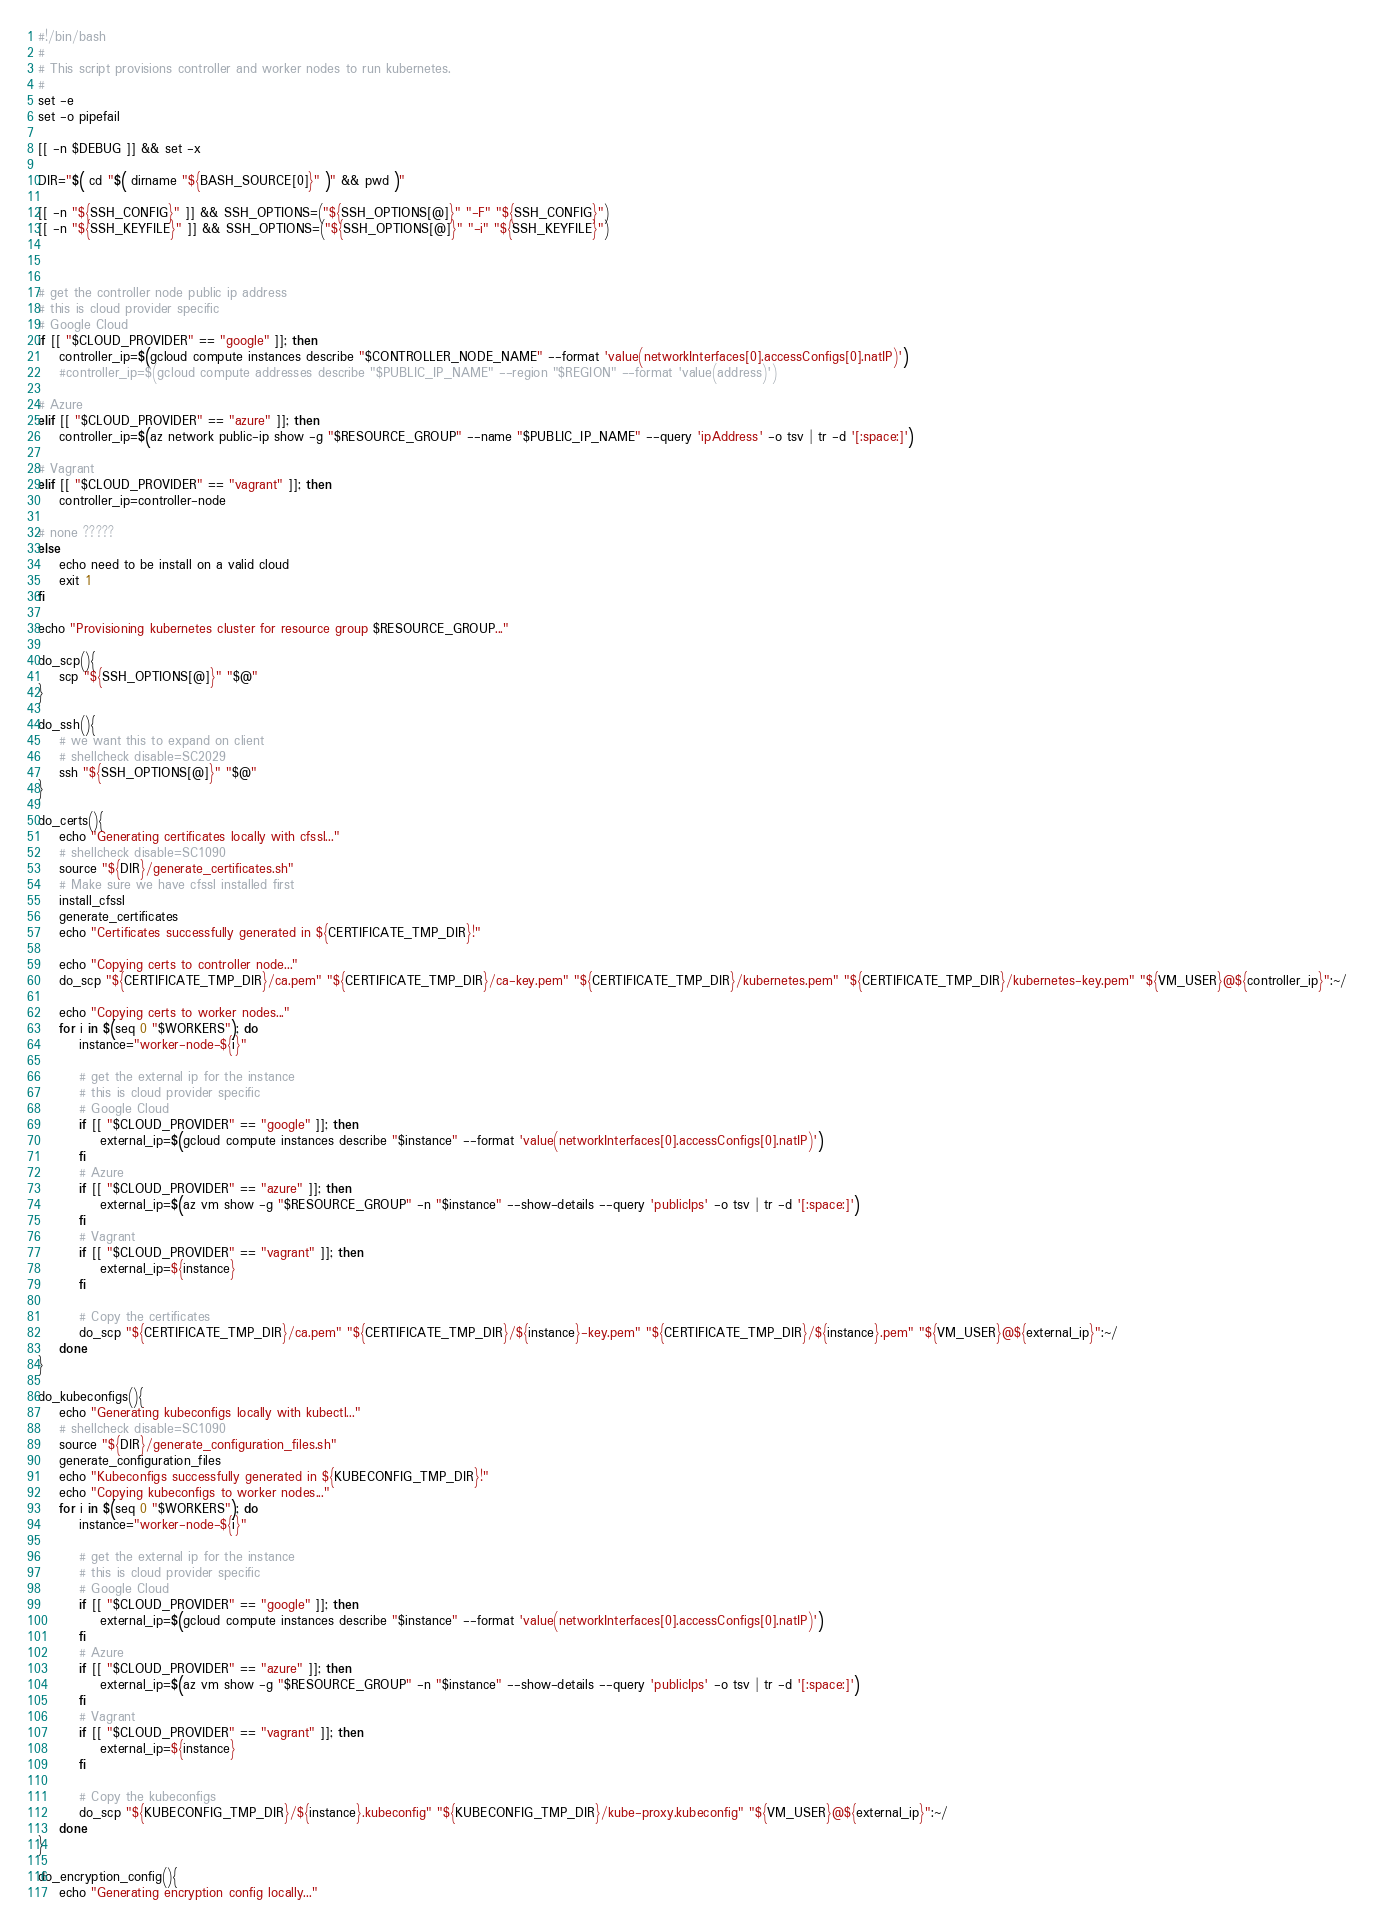<code> <loc_0><loc_0><loc_500><loc_500><_Bash_>#!/bin/bash
#
# This script provisions controller and worker nodes to run kubernetes.
#
set -e
set -o pipefail

[[ -n $DEBUG ]] && set -x

DIR="$( cd "$( dirname "${BASH_SOURCE[0]}" )" && pwd )"

[[ -n "${SSH_CONFIG}" ]] && SSH_OPTIONS=("${SSH_OPTIONS[@]}" "-F" "${SSH_CONFIG}")
[[ -n "${SSH_KEYFILE}" ]] && SSH_OPTIONS=("${SSH_OPTIONS[@]}" "-i" "${SSH_KEYFILE}")



# get the controller node public ip address
# this is cloud provider specific
# Google Cloud
if [[ "$CLOUD_PROVIDER" == "google" ]]; then
	controller_ip=$(gcloud compute instances describe "$CONTROLLER_NODE_NAME" --format 'value(networkInterfaces[0].accessConfigs[0].natIP)')
	#controller_ip=$(gcloud compute addresses describe "$PUBLIC_IP_NAME" --region "$REGION" --format 'value(address)')

# Azure
elif [[ "$CLOUD_PROVIDER" == "azure" ]]; then
	controller_ip=$(az network public-ip show -g "$RESOURCE_GROUP" --name "$PUBLIC_IP_NAME" --query 'ipAddress' -o tsv | tr -d '[:space:]')

# Vagrant
elif [[ "$CLOUD_PROVIDER" == "vagrant" ]]; then
	controller_ip=controller-node

# none ?????
else
	echo need to be install on a valid cloud
	exit 1
fi

echo "Provisioning kubernetes cluster for resource group $RESOURCE_GROUP..."

do_scp(){
	scp "${SSH_OPTIONS[@]}" "$@"
}

do_ssh(){
	# we want this to expand on client
	# shellcheck disable=SC2029
	ssh "${SSH_OPTIONS[@]}" "$@"
}

do_certs(){
	echo "Generating certificates locally with cfssl..."
	# shellcheck disable=SC1090
	source "${DIR}/generate_certificates.sh"
	# Make sure we have cfssl installed first
	install_cfssl
	generate_certificates
	echo "Certificates successfully generated in ${CERTIFICATE_TMP_DIR}!"

	echo "Copying certs to controller node..."
	do_scp "${CERTIFICATE_TMP_DIR}/ca.pem" "${CERTIFICATE_TMP_DIR}/ca-key.pem" "${CERTIFICATE_TMP_DIR}/kubernetes.pem" "${CERTIFICATE_TMP_DIR}/kubernetes-key.pem" "${VM_USER}@${controller_ip}":~/

	echo "Copying certs to worker nodes..."
	for i in $(seq 0 "$WORKERS"); do
		instance="worker-node-${i}"

		# get the external ip for the instance
		# this is cloud provider specific
		# Google Cloud
		if [[ "$CLOUD_PROVIDER" == "google" ]]; then
			external_ip=$(gcloud compute instances describe "$instance" --format 'value(networkInterfaces[0].accessConfigs[0].natIP)')
		fi
		# Azure
		if [[ "$CLOUD_PROVIDER" == "azure" ]]; then
			external_ip=$(az vm show -g "$RESOURCE_GROUP" -n "$instance" --show-details --query 'publicIps' -o tsv | tr -d '[:space:]')
		fi
		# Vagrant
		if [[ "$CLOUD_PROVIDER" == "vagrant" ]]; then
			external_ip=${instance}
		fi

		# Copy the certificates
		do_scp "${CERTIFICATE_TMP_DIR}/ca.pem" "${CERTIFICATE_TMP_DIR}/${instance}-key.pem" "${CERTIFICATE_TMP_DIR}/${instance}.pem" "${VM_USER}@${external_ip}":~/
	done
}

do_kubeconfigs(){
	echo "Generating kubeconfigs locally with kubectl..."
	# shellcheck disable=SC1090
	source "${DIR}/generate_configuration_files.sh"
	generate_configuration_files
	echo "Kubeconfigs successfully generated in ${KUBECONFIG_TMP_DIR}!"
	echo "Copying kubeconfigs to worker nodes..."
	for i in $(seq 0 "$WORKERS"); do
		instance="worker-node-${i}"

		# get the external ip for the instance
		# this is cloud provider specific
		# Google Cloud
		if [[ "$CLOUD_PROVIDER" == "google" ]]; then
			external_ip=$(gcloud compute instances describe "$instance" --format 'value(networkInterfaces[0].accessConfigs[0].natIP)')
		fi
		# Azure
		if [[ "$CLOUD_PROVIDER" == "azure" ]]; then
			external_ip=$(az vm show -g "$RESOURCE_GROUP" -n "$instance" --show-details --query 'publicIps' -o tsv | tr -d '[:space:]')
		fi
		# Vagrant
		if [[ "$CLOUD_PROVIDER" == "vagrant" ]]; then
			external_ip=${instance}
		fi

		# Copy the kubeconfigs
		do_scp "${KUBECONFIG_TMP_DIR}/${instance}.kubeconfig" "${KUBECONFIG_TMP_DIR}/kube-proxy.kubeconfig" "${VM_USER}@${external_ip}":~/
	done
}

do_encryption_config(){
	echo "Generating encryption config locally..."</code> 